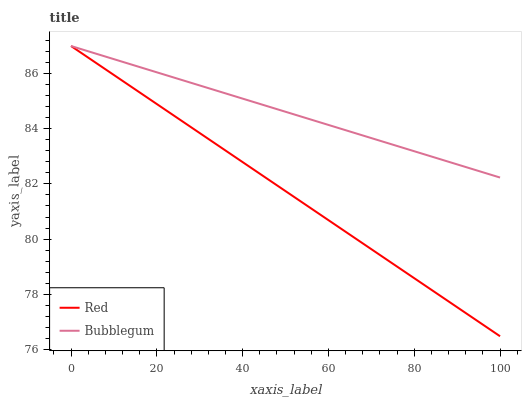Does Red have the minimum area under the curve?
Answer yes or no. Yes. Does Bubblegum have the maximum area under the curve?
Answer yes or no. Yes. Does Red have the maximum area under the curve?
Answer yes or no. No. Is Red the smoothest?
Answer yes or no. Yes. Is Bubblegum the roughest?
Answer yes or no. Yes. Is Red the roughest?
Answer yes or no. No. Does Red have the lowest value?
Answer yes or no. Yes. Does Red have the highest value?
Answer yes or no. Yes. Does Bubblegum intersect Red?
Answer yes or no. Yes. Is Bubblegum less than Red?
Answer yes or no. No. Is Bubblegum greater than Red?
Answer yes or no. No. 